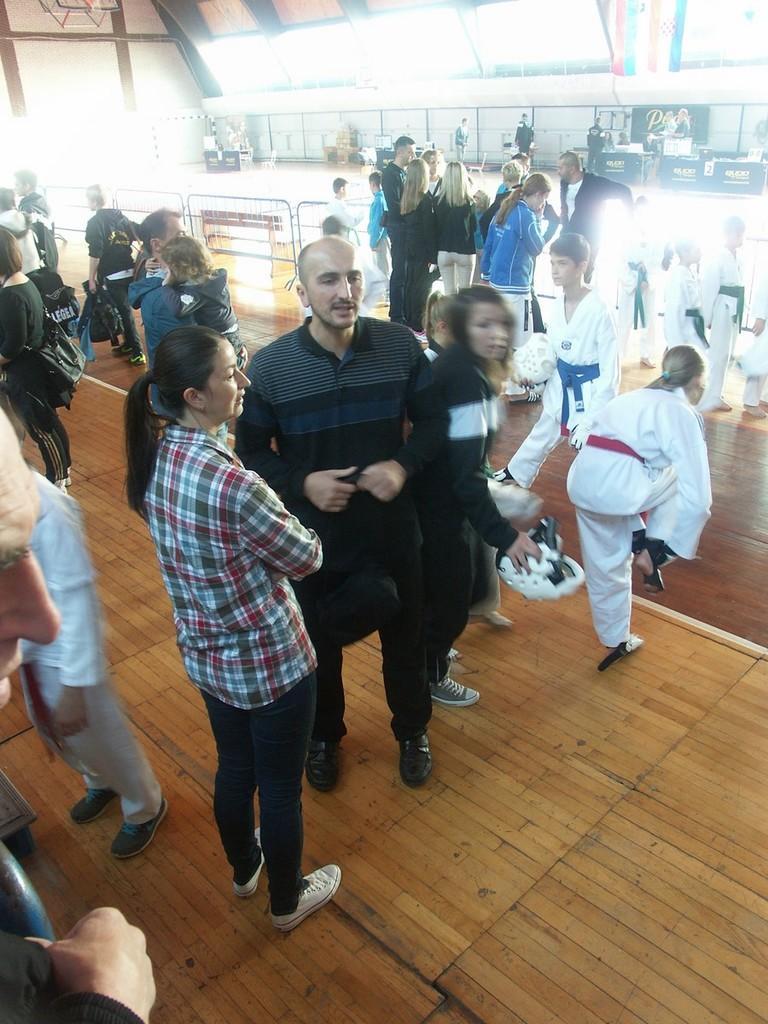Please provide a concise description of this image. In this image we can see some group of persons standing inside the indoor stadium, some persons wearing martial-art dress and in the background of the image there are some tables and a wall. 